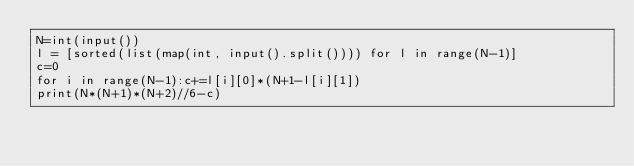Convert code to text. <code><loc_0><loc_0><loc_500><loc_500><_Python_>N=int(input())
l = [sorted(list(map(int, input().split()))) for l in range(N-1)]
c=0
for i in range(N-1):c+=l[i][0]*(N+1-l[i][1])
print(N*(N+1)*(N+2)//6-c)</code> 